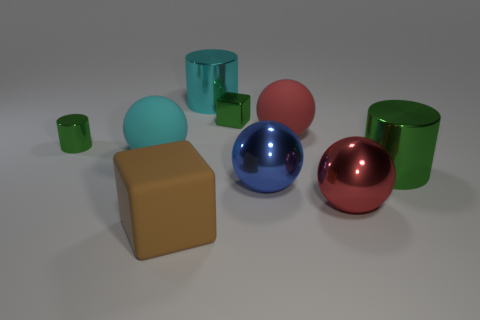There is a metal thing on the right side of the red metal object; is it the same shape as the big matte thing in front of the large green shiny object?
Offer a terse response. No. What color is the large shiny cylinder behind the green shiny object that is right of the rubber sphere right of the big cyan rubber ball?
Offer a very short reply. Cyan. What color is the matte block in front of the big red rubber object?
Your response must be concise. Brown. The cube that is the same size as the red shiny object is what color?
Offer a very short reply. Brown. Does the blue metal sphere have the same size as the cyan metallic cylinder?
Give a very brief answer. Yes. There is a cyan cylinder; what number of large cyan rubber objects are behind it?
Offer a terse response. 0. What number of things are either big things that are right of the big block or yellow rubber things?
Offer a terse response. 5. Are there more red shiny things that are left of the big red rubber sphere than big brown cubes in front of the brown thing?
Your answer should be compact. No. The other cylinder that is the same color as the small cylinder is what size?
Your response must be concise. Large. Does the cyan cylinder have the same size as the rubber object in front of the large blue shiny object?
Offer a terse response. Yes. 